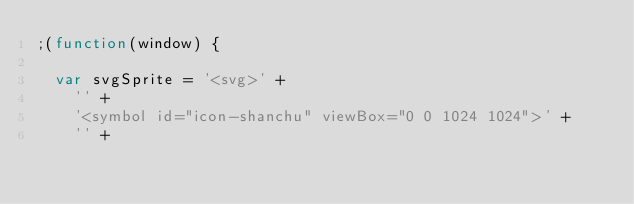Convert code to text. <code><loc_0><loc_0><loc_500><loc_500><_JavaScript_>;(function(window) {

  var svgSprite = '<svg>' +
    '' +
    '<symbol id="icon-shanchu" viewBox="0 0 1024 1024">' +
    '' +</code> 